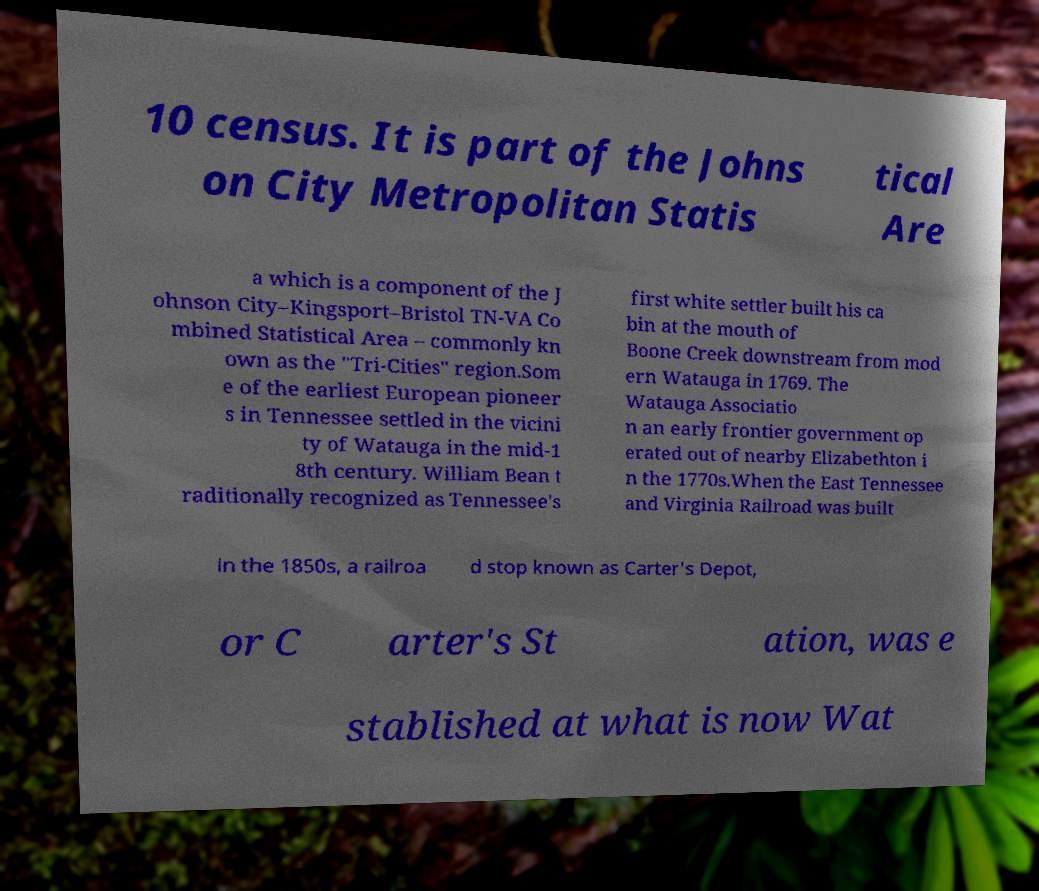Can you read and provide the text displayed in the image?This photo seems to have some interesting text. Can you extract and type it out for me? 10 census. It is part of the Johns on City Metropolitan Statis tical Are a which is a component of the J ohnson City–Kingsport–Bristol TN-VA Co mbined Statistical Area – commonly kn own as the "Tri-Cities" region.Som e of the earliest European pioneer s in Tennessee settled in the vicini ty of Watauga in the mid-1 8th century. William Bean t raditionally recognized as Tennessee's first white settler built his ca bin at the mouth of Boone Creek downstream from mod ern Watauga in 1769. The Watauga Associatio n an early frontier government op erated out of nearby Elizabethton i n the 1770s.When the East Tennessee and Virginia Railroad was built in the 1850s, a railroa d stop known as Carter's Depot, or C arter's St ation, was e stablished at what is now Wat 